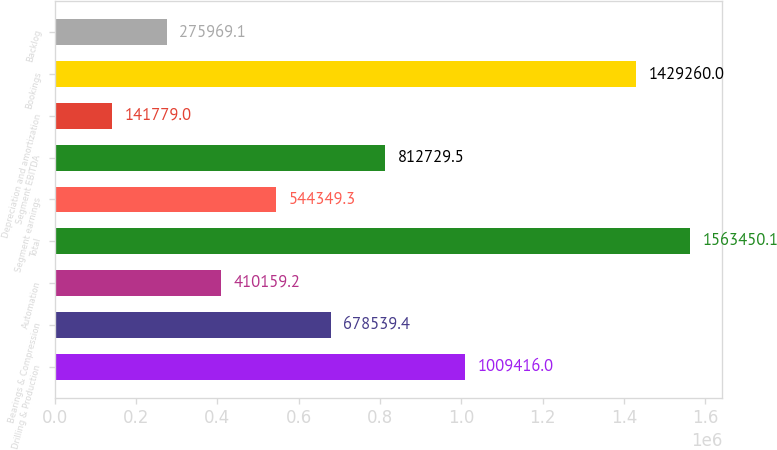Convert chart. <chart><loc_0><loc_0><loc_500><loc_500><bar_chart><fcel>Drilling & Production<fcel>Bearings & Compression<fcel>Automation<fcel>Total<fcel>Segment earnings<fcel>Segment EBITDA<fcel>Depreciation and amortization<fcel>Bookings<fcel>Backlog<nl><fcel>1.00942e+06<fcel>678539<fcel>410159<fcel>1.56345e+06<fcel>544349<fcel>812730<fcel>141779<fcel>1.42926e+06<fcel>275969<nl></chart> 